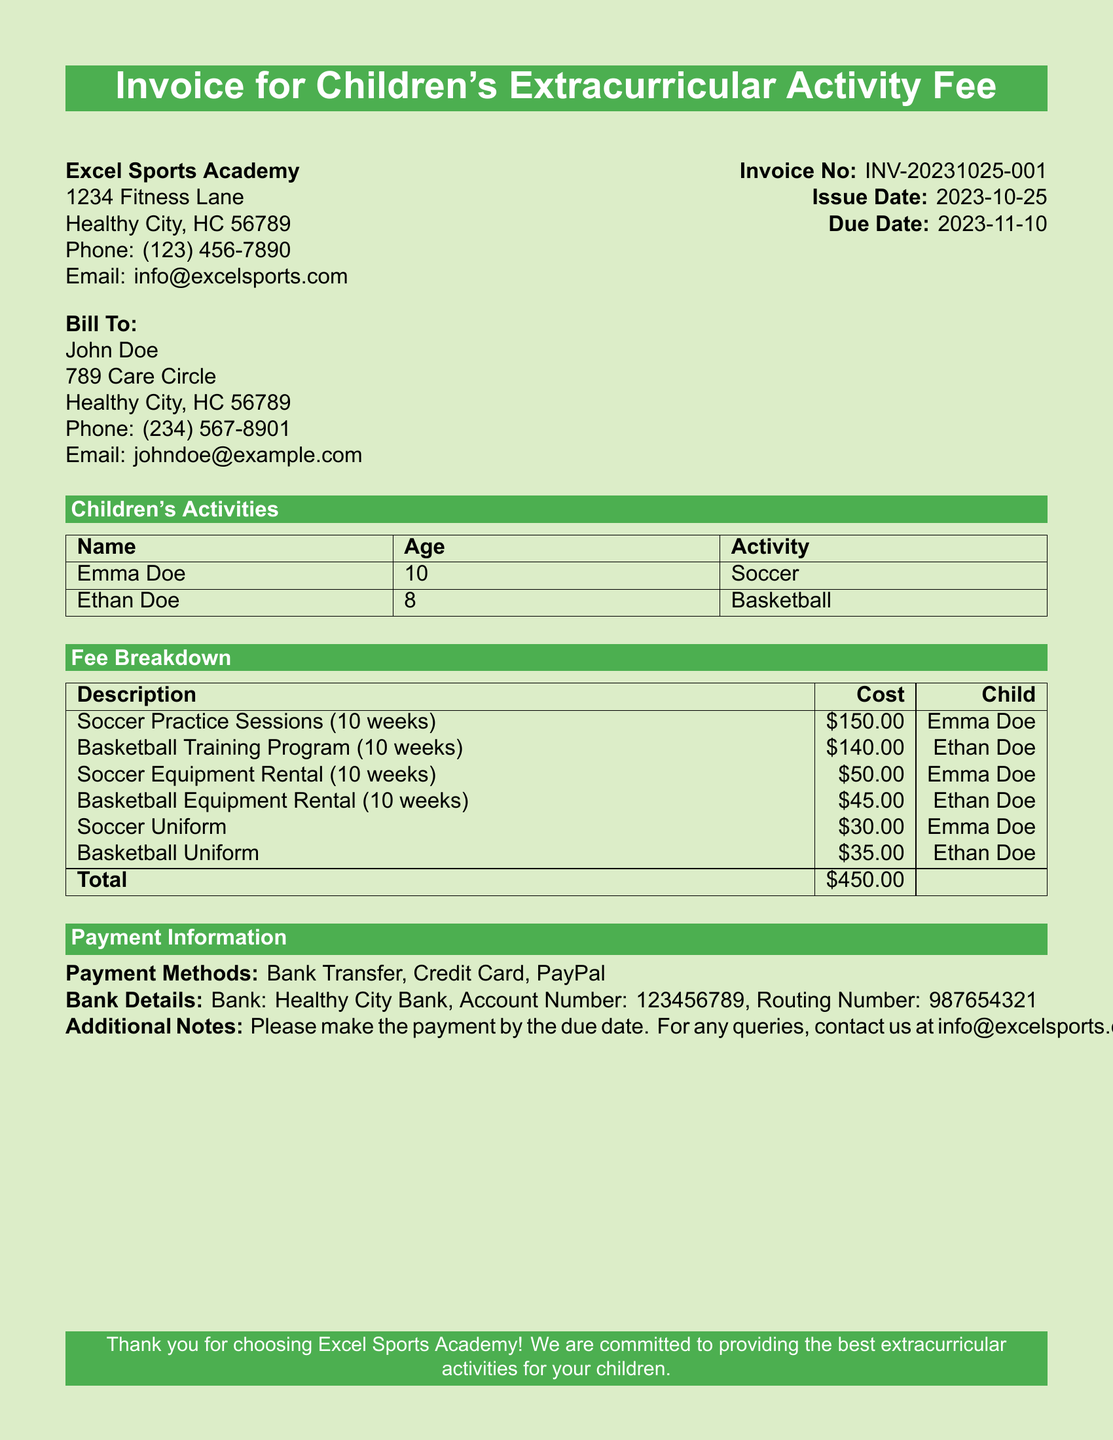What is the invoice number? The invoice number is listed as a unique identifier for the document, found in the header section.
Answer: INV-20231025-001 Who is the bill recipient? The bill recipient's name is provided under the "Bill To" section of the document.
Answer: John Doe What is the total amount due? The total amount due is calculated by summing all costs listed in the fee breakdown.
Answer: $450.00 When is the due date for the invoice? The due date is specified in the header section of the document and indicates when payment is expected.
Answer: 2023-11-10 How much is the soccer uniform cost? The cost of the soccer uniform is detailed in the fee breakdown section.
Answer: $30.00 What activities are the children enrolled in? The document lists the activities corresponding to each child in the activities table.
Answer: Soccer, Basketball What is the payment method mentioned? The payment methods available for processing the invoice are listed in the payment information section.
Answer: Bank Transfer, Credit Card, PayPal Which child is associated with the basketball equipment rental? The document provides details on which child is linked to each fee, including equipment rentals.
Answer: Ethan Doe 